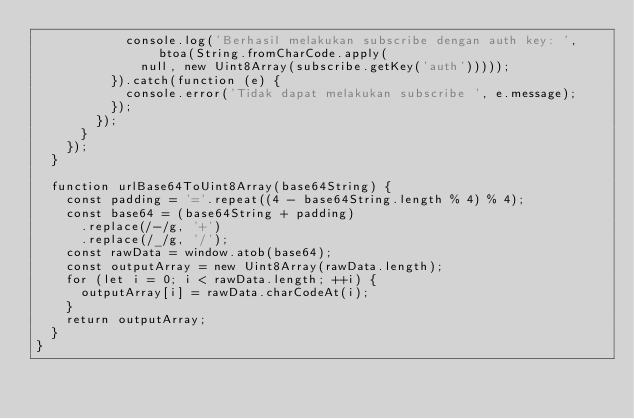<code> <loc_0><loc_0><loc_500><loc_500><_JavaScript_>            console.log('Berhasil melakukan subscribe dengan auth key: ', btoa(String.fromCharCode.apply(
              null, new Uint8Array(subscribe.getKey('auth')))));
          }).catch(function (e) {
            console.error('Tidak dapat melakukan subscribe ', e.message);
          });
        });
      }
    });
  }

  function urlBase64ToUint8Array(base64String) {
    const padding = '='.repeat((4 - base64String.length % 4) % 4);
    const base64 = (base64String + padding)
      .replace(/-/g, '+')
      .replace(/_/g, '/');
    const rawData = window.atob(base64);
    const outputArray = new Uint8Array(rawData.length);
    for (let i = 0; i < rawData.length; ++i) {
      outputArray[i] = rawData.charCodeAt(i);
    }
    return outputArray;
  }
}</code> 